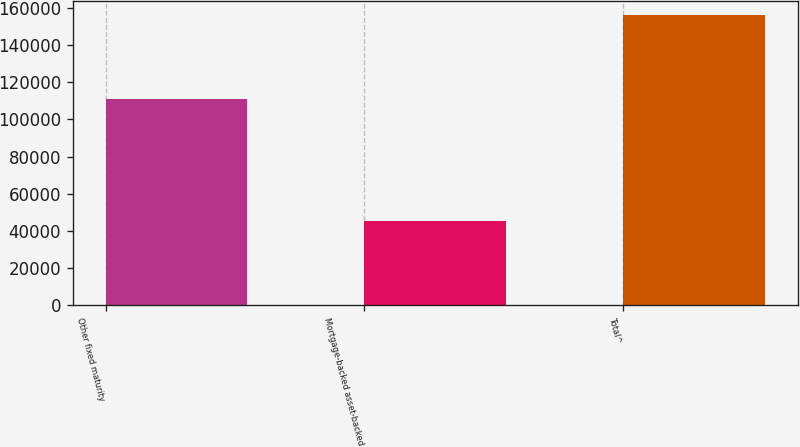<chart> <loc_0><loc_0><loc_500><loc_500><bar_chart><fcel>Other fixed maturity<fcel>Mortgage-backed asset-backed<fcel>Total^<nl><fcel>110829<fcel>45422<fcel>156251<nl></chart> 